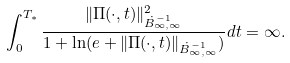<formula> <loc_0><loc_0><loc_500><loc_500>\int _ { 0 } ^ { T _ { * } } \frac { \| \Pi ( \cdot , t ) \| _ { \dot { B } ^ { - 1 } _ { \infty , \infty } } ^ { 2 } } { 1 + \ln ( e + \| \Pi ( \cdot , t ) \| _ { \dot { B } ^ { - 1 } _ { \infty , \infty } } ) } d t = \infty .</formula> 